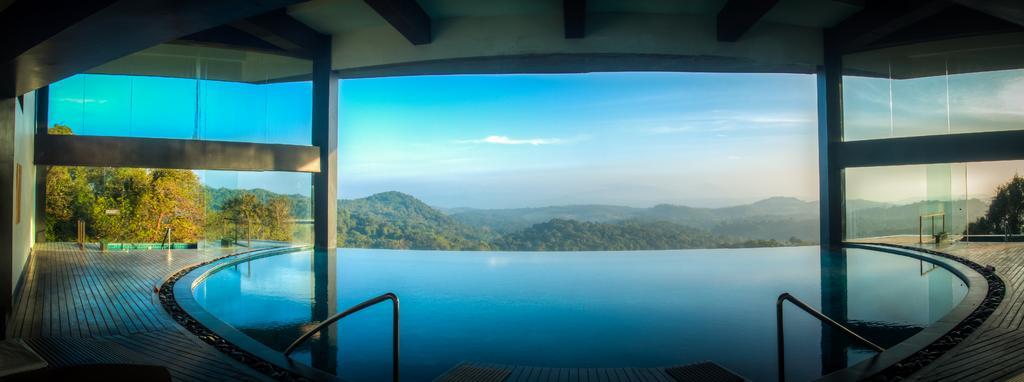Could you give a brief overview of what you see in this image? In this image there is wall, pillars with roof and trees in the left and right corner. There is water, trees and mountains in the background. And there is a sky at the top. 